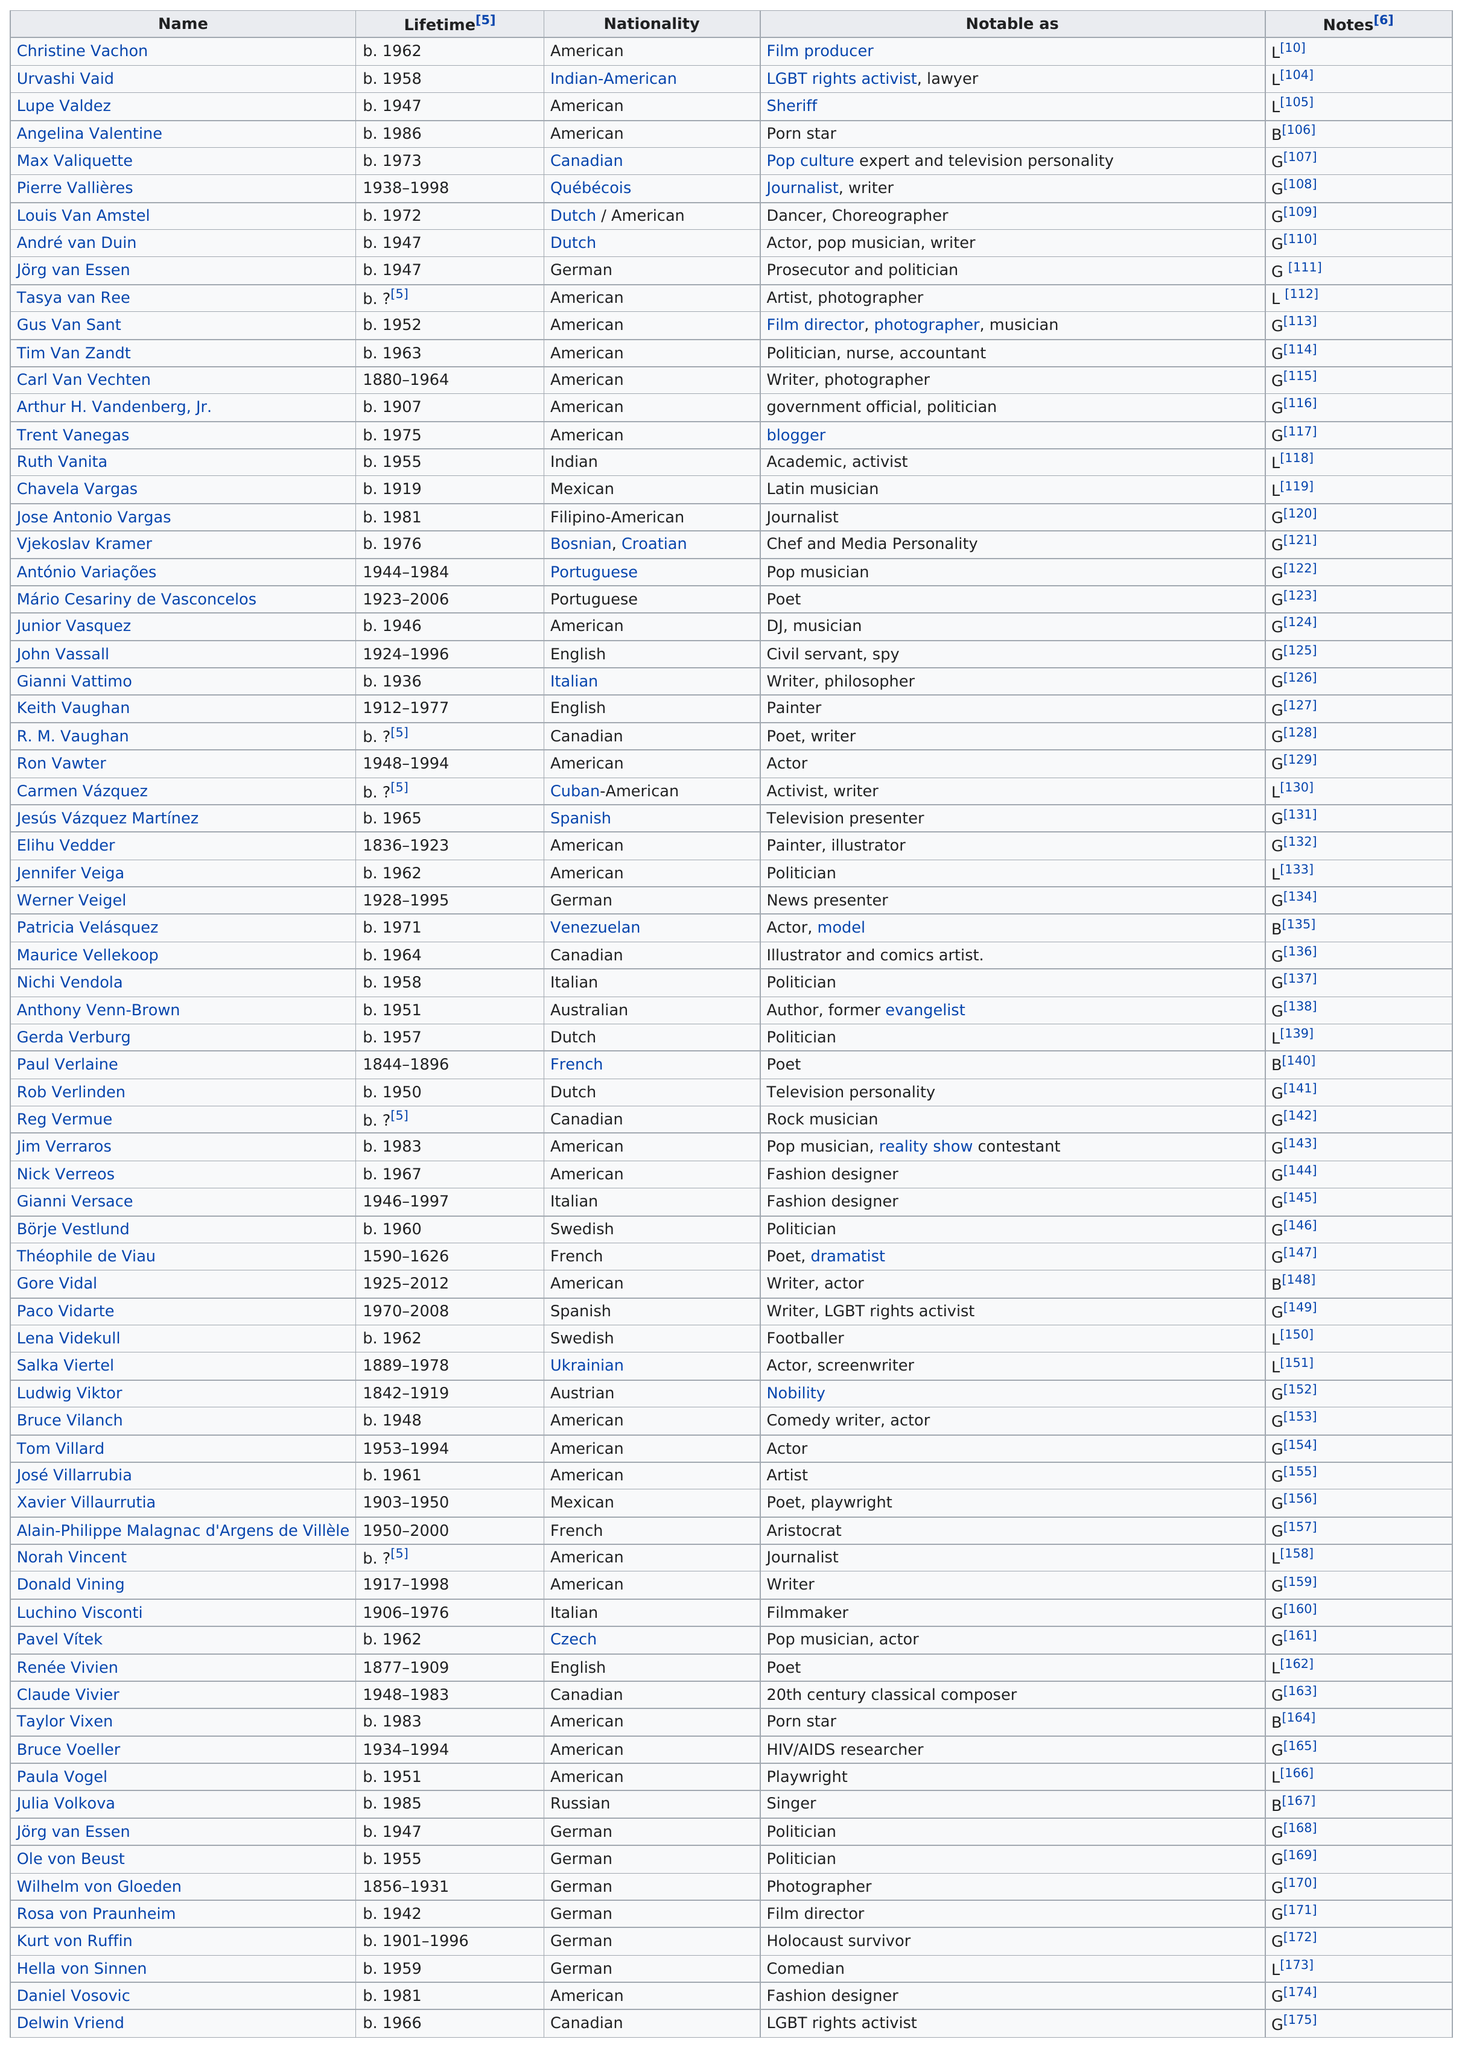Point out several critical features in this image. The nationality with the most people associated with it is American. The nationality that had the larger amount of names listed was American. The notes after L are the other notes. Pierre Vallieres was 60 years old when he died. Vachon and Vaid were born 4 years apart. 